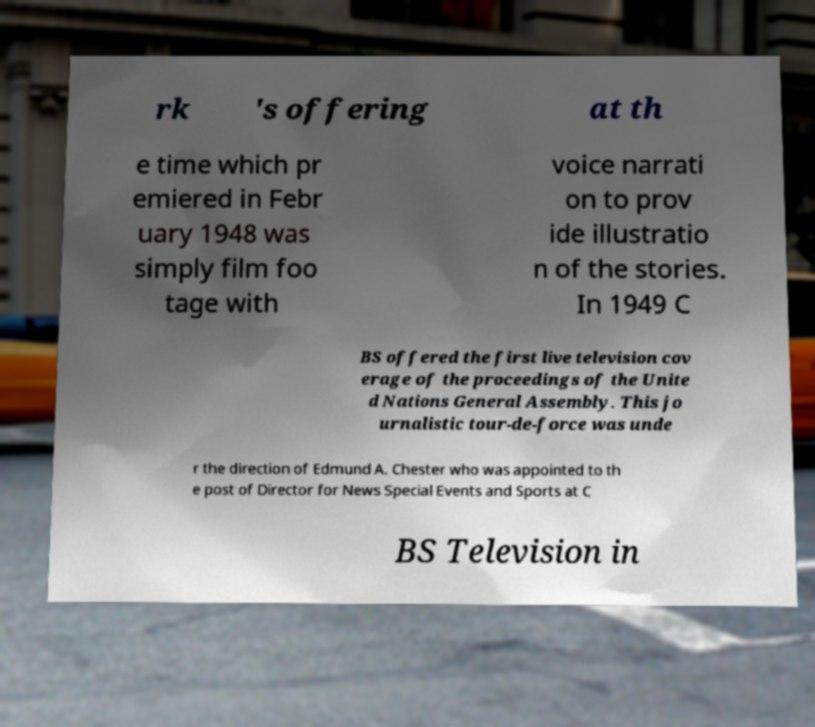There's text embedded in this image that I need extracted. Can you transcribe it verbatim? rk 's offering at th e time which pr emiered in Febr uary 1948 was simply film foo tage with voice narrati on to prov ide illustratio n of the stories. In 1949 C BS offered the first live television cov erage of the proceedings of the Unite d Nations General Assembly. This jo urnalistic tour-de-force was unde r the direction of Edmund A. Chester who was appointed to th e post of Director for News Special Events and Sports at C BS Television in 